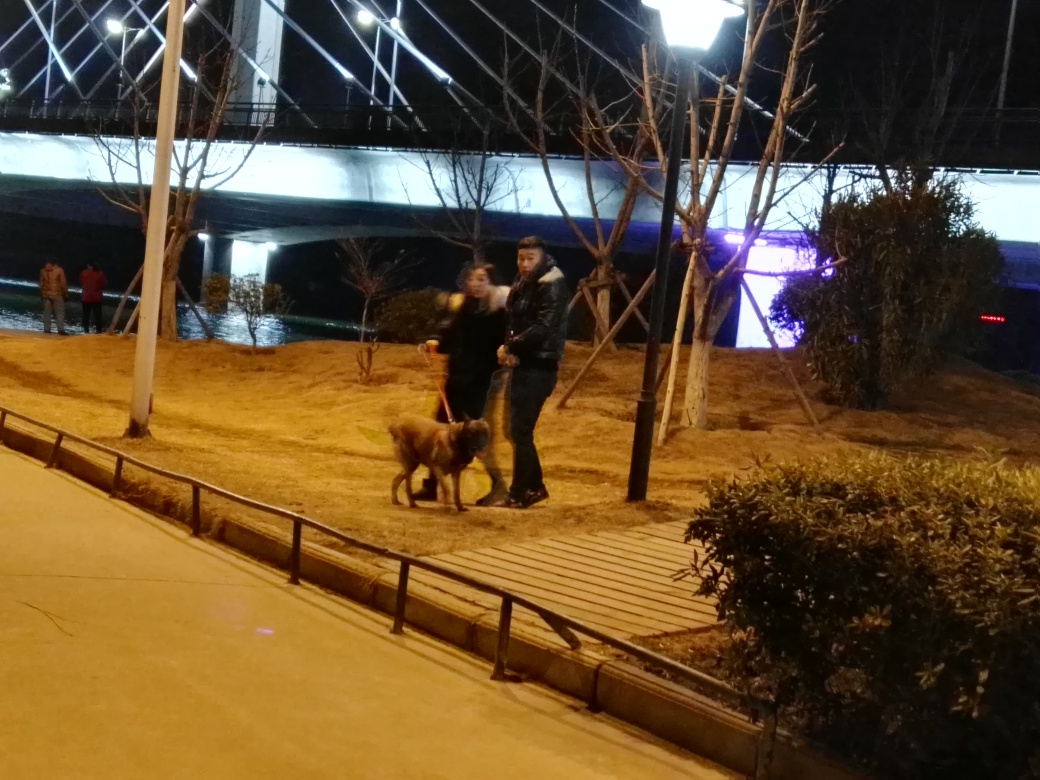What time of day does this image seem to be taken? The photo appears to have been taken in the evening or at night, as indicated by the artificial lighting and the dark sky. 